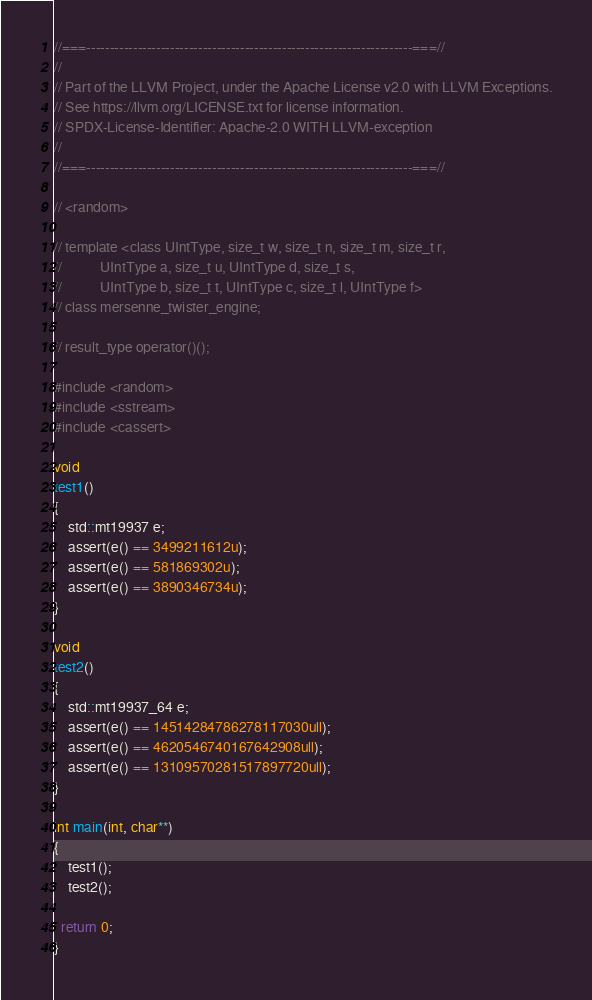<code> <loc_0><loc_0><loc_500><loc_500><_C++_>//===----------------------------------------------------------------------===//
//
// Part of the LLVM Project, under the Apache License v2.0 with LLVM Exceptions.
// See https://llvm.org/LICENSE.txt for license information.
// SPDX-License-Identifier: Apache-2.0 WITH LLVM-exception
//
//===----------------------------------------------------------------------===//

// <random>

// template <class UIntType, size_t w, size_t n, size_t m, size_t r,
//           UIntType a, size_t u, UIntType d, size_t s,
//           UIntType b, size_t t, UIntType c, size_t l, UIntType f>
// class mersenne_twister_engine;

// result_type operator()();

#include <random>
#include <sstream>
#include <cassert>

void
test1()
{
    std::mt19937 e;
    assert(e() == 3499211612u);
    assert(e() == 581869302u);
    assert(e() == 3890346734u);
}

void
test2()
{
    std::mt19937_64 e;
    assert(e() == 14514284786278117030ull);
    assert(e() == 4620546740167642908ull);
    assert(e() == 13109570281517897720ull);
}

int main(int, char**)
{
    test1();
    test2();

  return 0;
}
</code> 